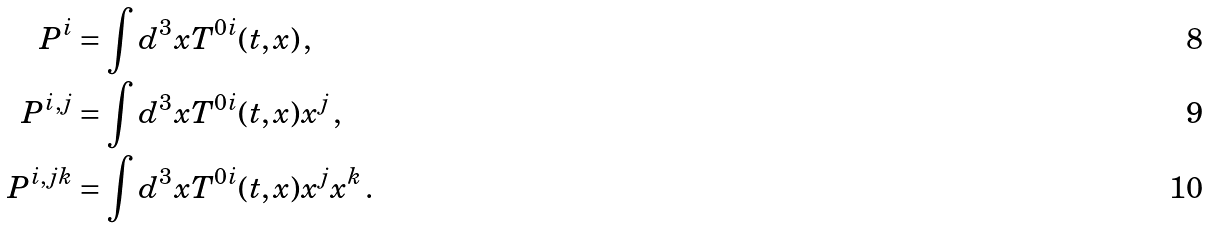Convert formula to latex. <formula><loc_0><loc_0><loc_500><loc_500>P ^ { i } & = \int d ^ { 3 } x T ^ { 0 i } ( t , x ) \, , \\ P ^ { i , j } & = \int d ^ { 3 } x T ^ { 0 i } ( t , x ) x ^ { j } \, , \\ P ^ { i , j k } & = \int d ^ { 3 } x T ^ { 0 i } ( t , x ) x ^ { j } x ^ { k } \, .</formula> 